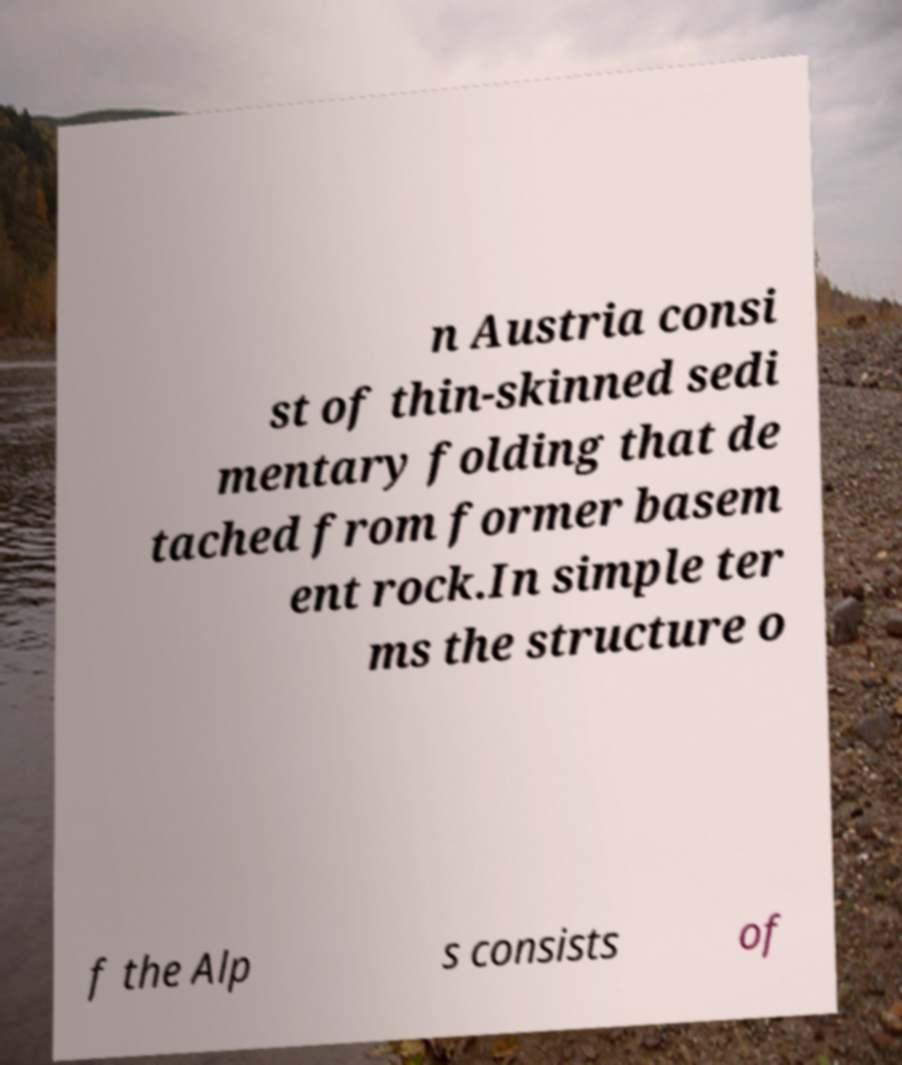Please read and relay the text visible in this image. What does it say? n Austria consi st of thin-skinned sedi mentary folding that de tached from former basem ent rock.In simple ter ms the structure o f the Alp s consists of 